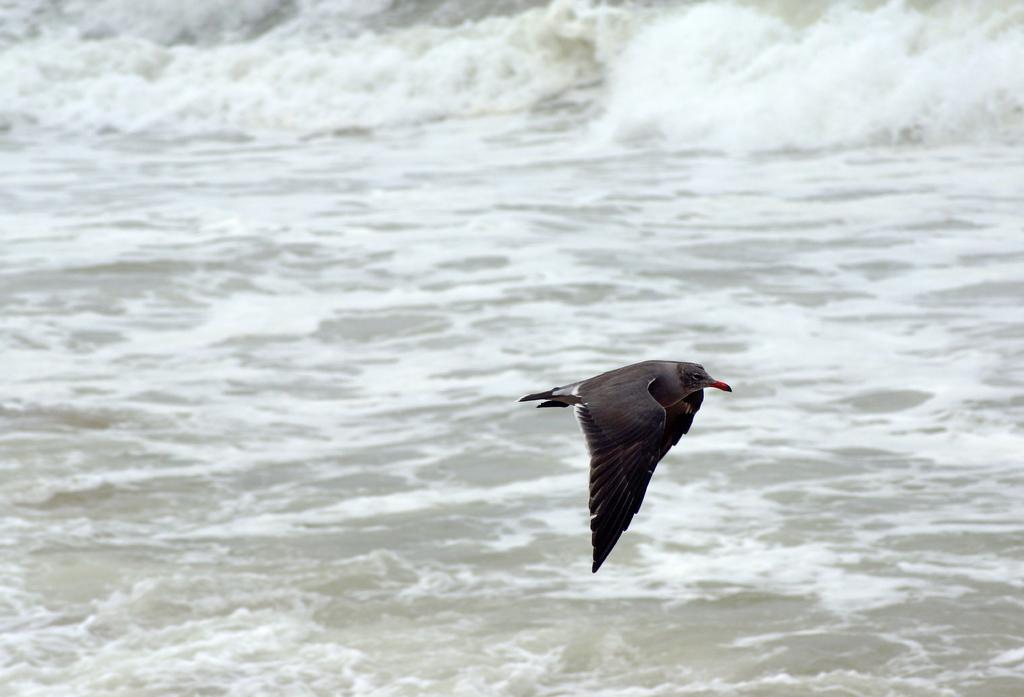How would you summarize this image in a sentence or two? In this image we can see a bird which is in black color flying in air and we can see some water. 